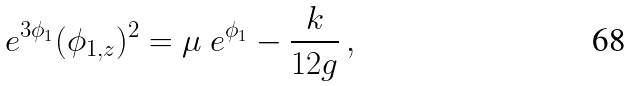<formula> <loc_0><loc_0><loc_500><loc_500>\ e ^ { 3 \phi _ { 1 } } ( \phi _ { 1 , z } ) ^ { 2 } = \mu \ e ^ { \phi _ { 1 } } - \frac { k } { 1 2 g } \, ,</formula> 